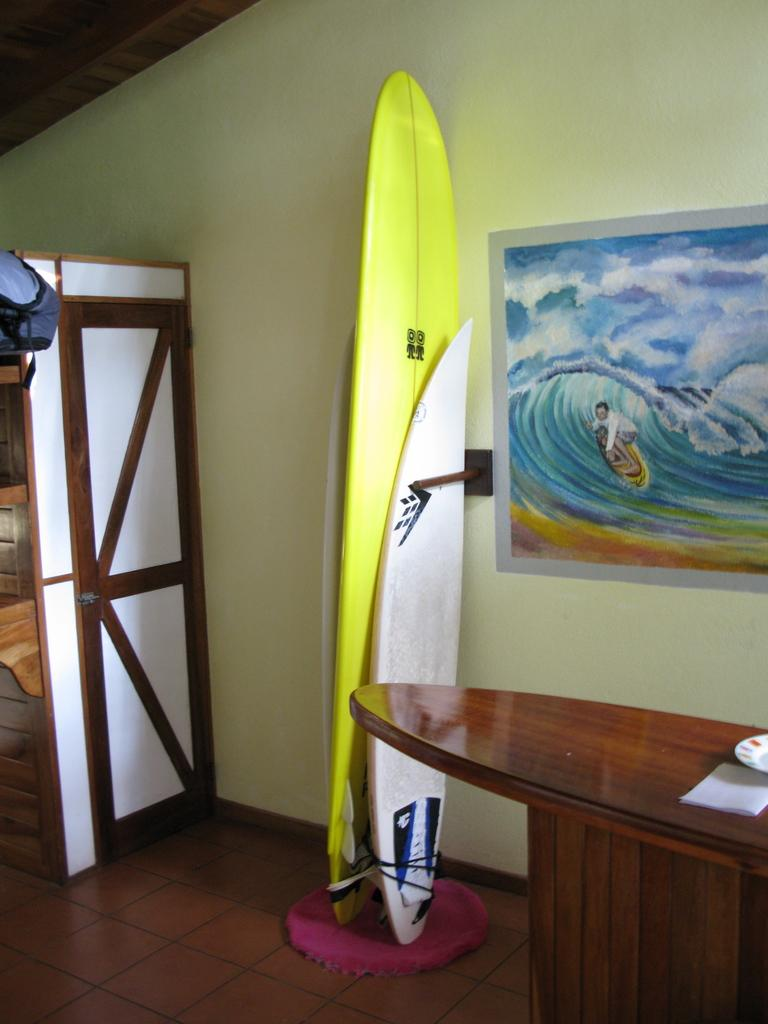What object is near the wall in the image? There is a surfboard near the wall in the image. What is in front of the wall? There is a table in front of the wall. What can be seen in the background of the image? There is a door visible in the background. What decorative item is on the wall? There is a painting on the wall. What type of bait is being used to catch fish in the image? There is no fishing or bait present in the image; it features a surfboard, a table, a door, and a painting on the wall. Can you see any celery in the image? There is no celery present in the image. 